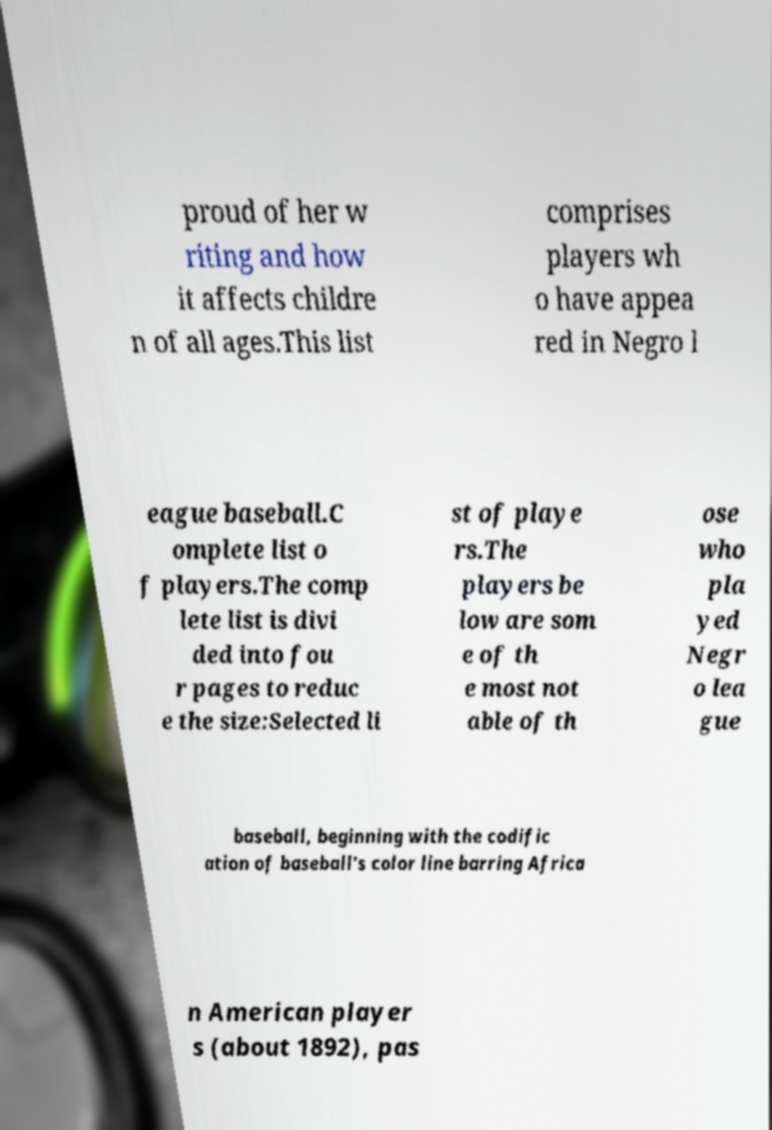Can you read and provide the text displayed in the image?This photo seems to have some interesting text. Can you extract and type it out for me? proud of her w riting and how it affects childre n of all ages.This list comprises players wh o have appea red in Negro l eague baseball.C omplete list o f players.The comp lete list is divi ded into fou r pages to reduc e the size:Selected li st of playe rs.The players be low are som e of th e most not able of th ose who pla yed Negr o lea gue baseball, beginning with the codific ation of baseball's color line barring Africa n American player s (about 1892), pas 